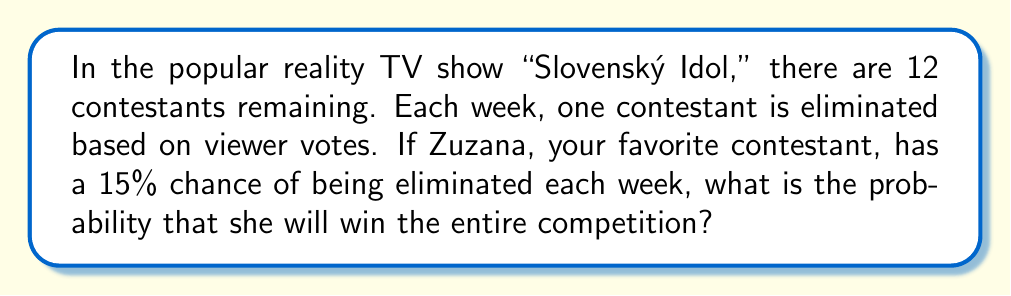Could you help me with this problem? Let's approach this step-by-step:

1) For Zuzana to win, she needs to survive 11 eliminations (as she's competing against 11 other contestants).

2) The probability of Zuzana surviving one week is the complement of her being eliminated:
   $P(\text{surviving one week}) = 1 - P(\text{being eliminated}) = 1 - 0.15 = 0.85$

3) To win, Zuzana needs to survive 11 consecutive weeks. Since each week's elimination is independent, we can use the multiplication rule of probability.

4) The probability of surviving all 11 weeks is:
   $P(\text{winning}) = 0.85^{11}$

5) Let's calculate this:
   $$\begin{align}
   P(\text{winning}) &= 0.85^{11} \\
   &\approx 0.1670
   \end{align}$$

6) Convert to a percentage:
   $0.1670 \times 100\% \approx 16.70\%$

Therefore, Zuzana has approximately a 16.70% chance of winning the entire competition.
Answer: 16.70% 